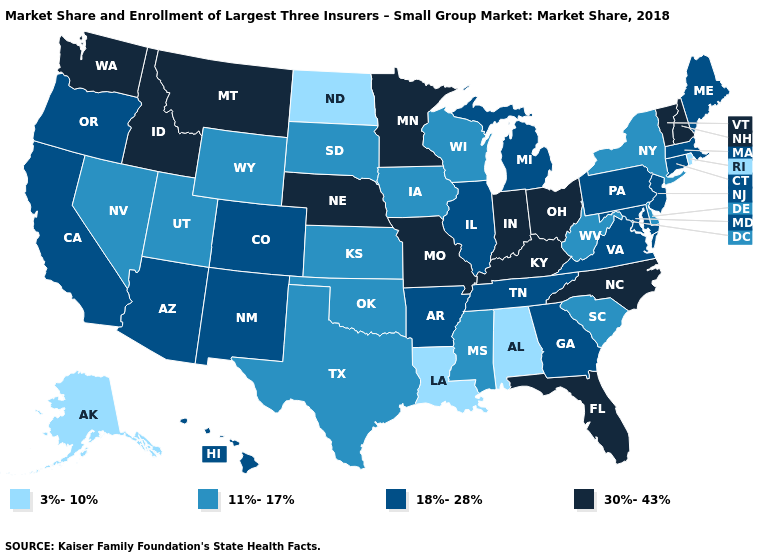What is the lowest value in the USA?
Quick response, please. 3%-10%. What is the value of Kentucky?
Short answer required. 30%-43%. Does the map have missing data?
Give a very brief answer. No. Does Mississippi have the highest value in the South?
Answer briefly. No. Name the states that have a value in the range 18%-28%?
Quick response, please. Arizona, Arkansas, California, Colorado, Connecticut, Georgia, Hawaii, Illinois, Maine, Maryland, Massachusetts, Michigan, New Jersey, New Mexico, Oregon, Pennsylvania, Tennessee, Virginia. What is the lowest value in the West?
Quick response, please. 3%-10%. Does Utah have a lower value than Alabama?
Quick response, please. No. Does Oregon have the highest value in the West?
Answer briefly. No. What is the value of West Virginia?
Be succinct. 11%-17%. Does Louisiana have the highest value in the USA?
Write a very short answer. No. Which states hav the highest value in the MidWest?
Give a very brief answer. Indiana, Minnesota, Missouri, Nebraska, Ohio. Does the map have missing data?
Concise answer only. No. What is the highest value in the USA?
Keep it brief. 30%-43%. Does Texas have the lowest value in the USA?
Be succinct. No. Among the states that border Utah , does Arizona have the lowest value?
Give a very brief answer. No. 